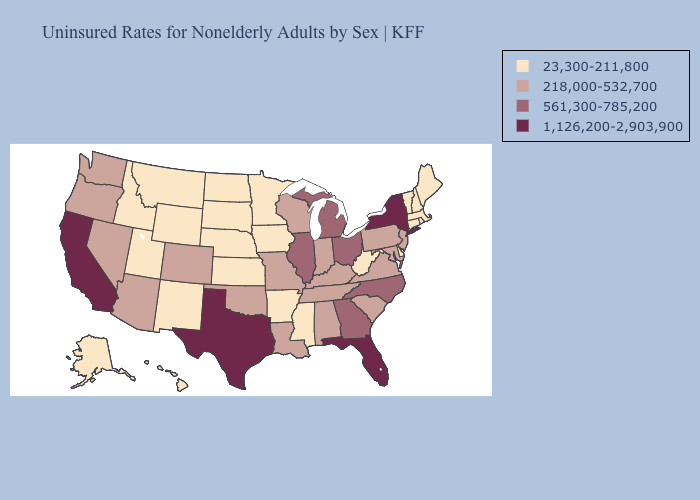Does the first symbol in the legend represent the smallest category?
Concise answer only. Yes. Does Idaho have a higher value than Oklahoma?
Give a very brief answer. No. Does the first symbol in the legend represent the smallest category?
Short answer required. Yes. Does Michigan have the lowest value in the MidWest?
Give a very brief answer. No. Is the legend a continuous bar?
Keep it brief. No. What is the value of Montana?
Concise answer only. 23,300-211,800. What is the value of Iowa?
Short answer required. 23,300-211,800. Does Arizona have a lower value than Illinois?
Quick response, please. Yes. Name the states that have a value in the range 23,300-211,800?
Write a very short answer. Alaska, Arkansas, Connecticut, Delaware, Hawaii, Idaho, Iowa, Kansas, Maine, Massachusetts, Minnesota, Mississippi, Montana, Nebraska, New Hampshire, New Mexico, North Dakota, Rhode Island, South Dakota, Utah, Vermont, West Virginia, Wyoming. What is the value of New Jersey?
Give a very brief answer. 218,000-532,700. Among the states that border Arizona , which have the highest value?
Give a very brief answer. California. Does the first symbol in the legend represent the smallest category?
Concise answer only. Yes. Name the states that have a value in the range 1,126,200-2,903,900?
Give a very brief answer. California, Florida, New York, Texas. Which states have the lowest value in the West?
Concise answer only. Alaska, Hawaii, Idaho, Montana, New Mexico, Utah, Wyoming. What is the highest value in the MidWest ?
Answer briefly. 561,300-785,200. 